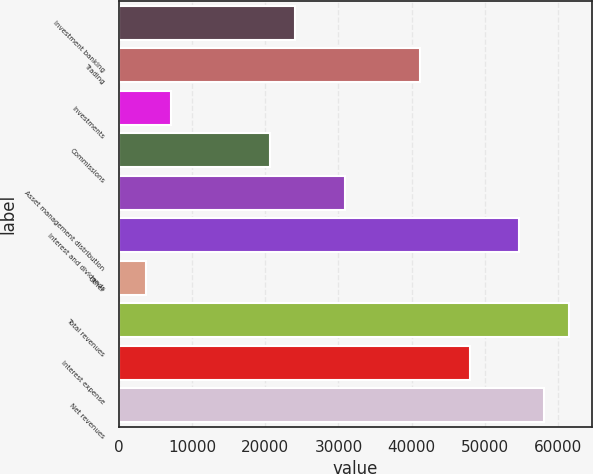Convert chart. <chart><loc_0><loc_0><loc_500><loc_500><bar_chart><fcel>Investment banking<fcel>Trading<fcel>Investments<fcel>Commissions<fcel>Asset management distribution<fcel>Interest and dividends<fcel>Other<fcel>Total revenues<fcel>Interest expense<fcel>Net revenues<nl><fcel>24105.6<fcel>41089.6<fcel>7121.6<fcel>20708.8<fcel>30899.2<fcel>54676.8<fcel>3724.8<fcel>61470.4<fcel>47883.2<fcel>58073.6<nl></chart> 